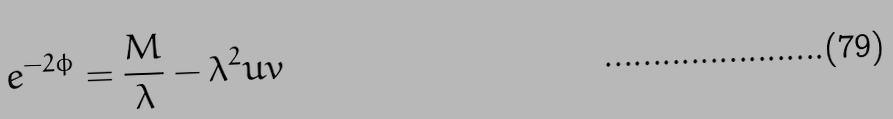<formula> <loc_0><loc_0><loc_500><loc_500>e ^ { - 2 \phi } = { \frac { M } { \lambda } } - \lambda ^ { 2 } u v</formula> 